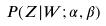Convert formula to latex. <formula><loc_0><loc_0><loc_500><loc_500>P ( Z | W ; \alpha , \beta )</formula> 